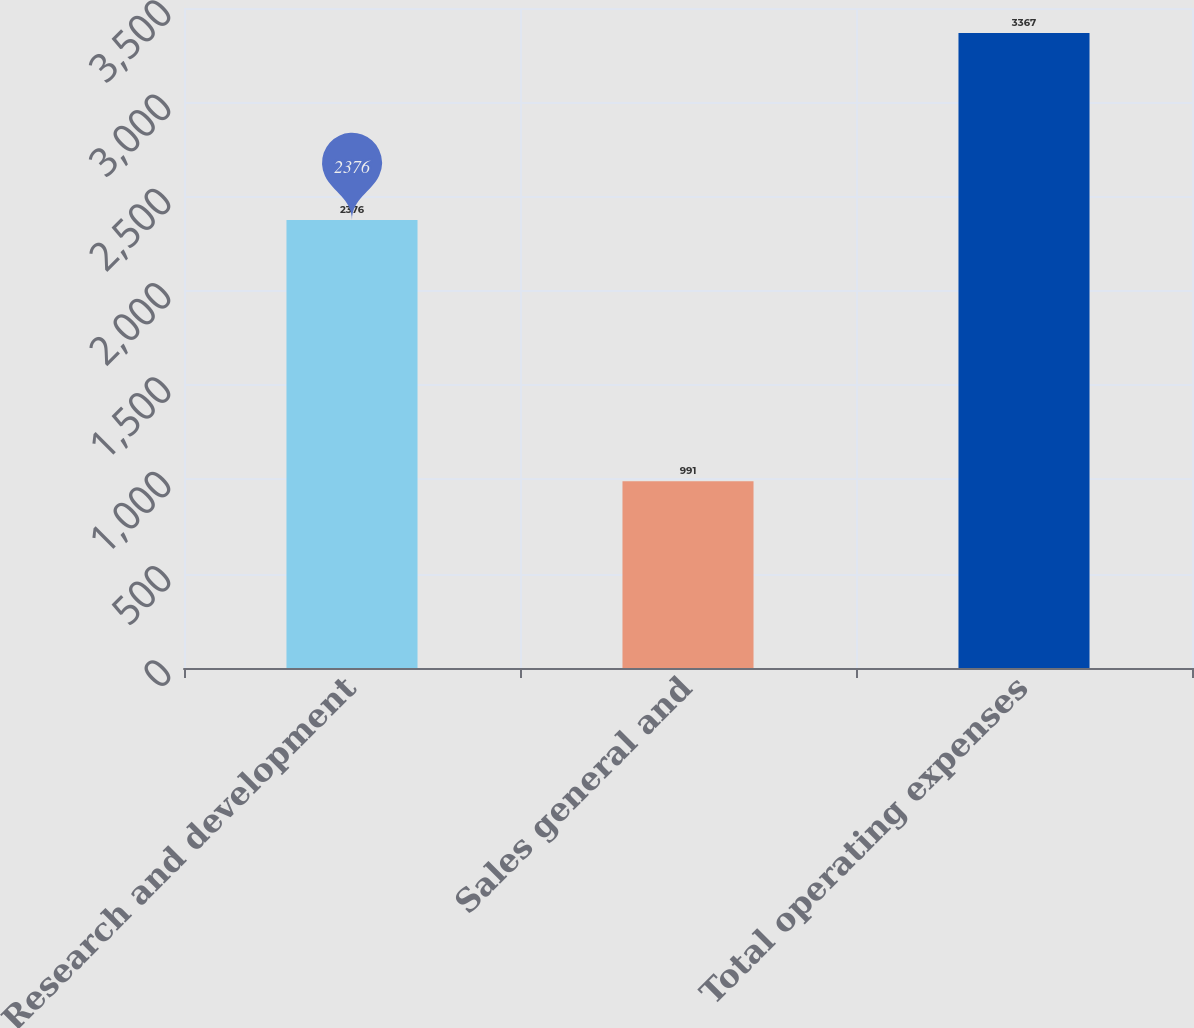Convert chart to OTSL. <chart><loc_0><loc_0><loc_500><loc_500><bar_chart><fcel>Research and development<fcel>Sales general and<fcel>Total operating expenses<nl><fcel>2376<fcel>991<fcel>3367<nl></chart> 